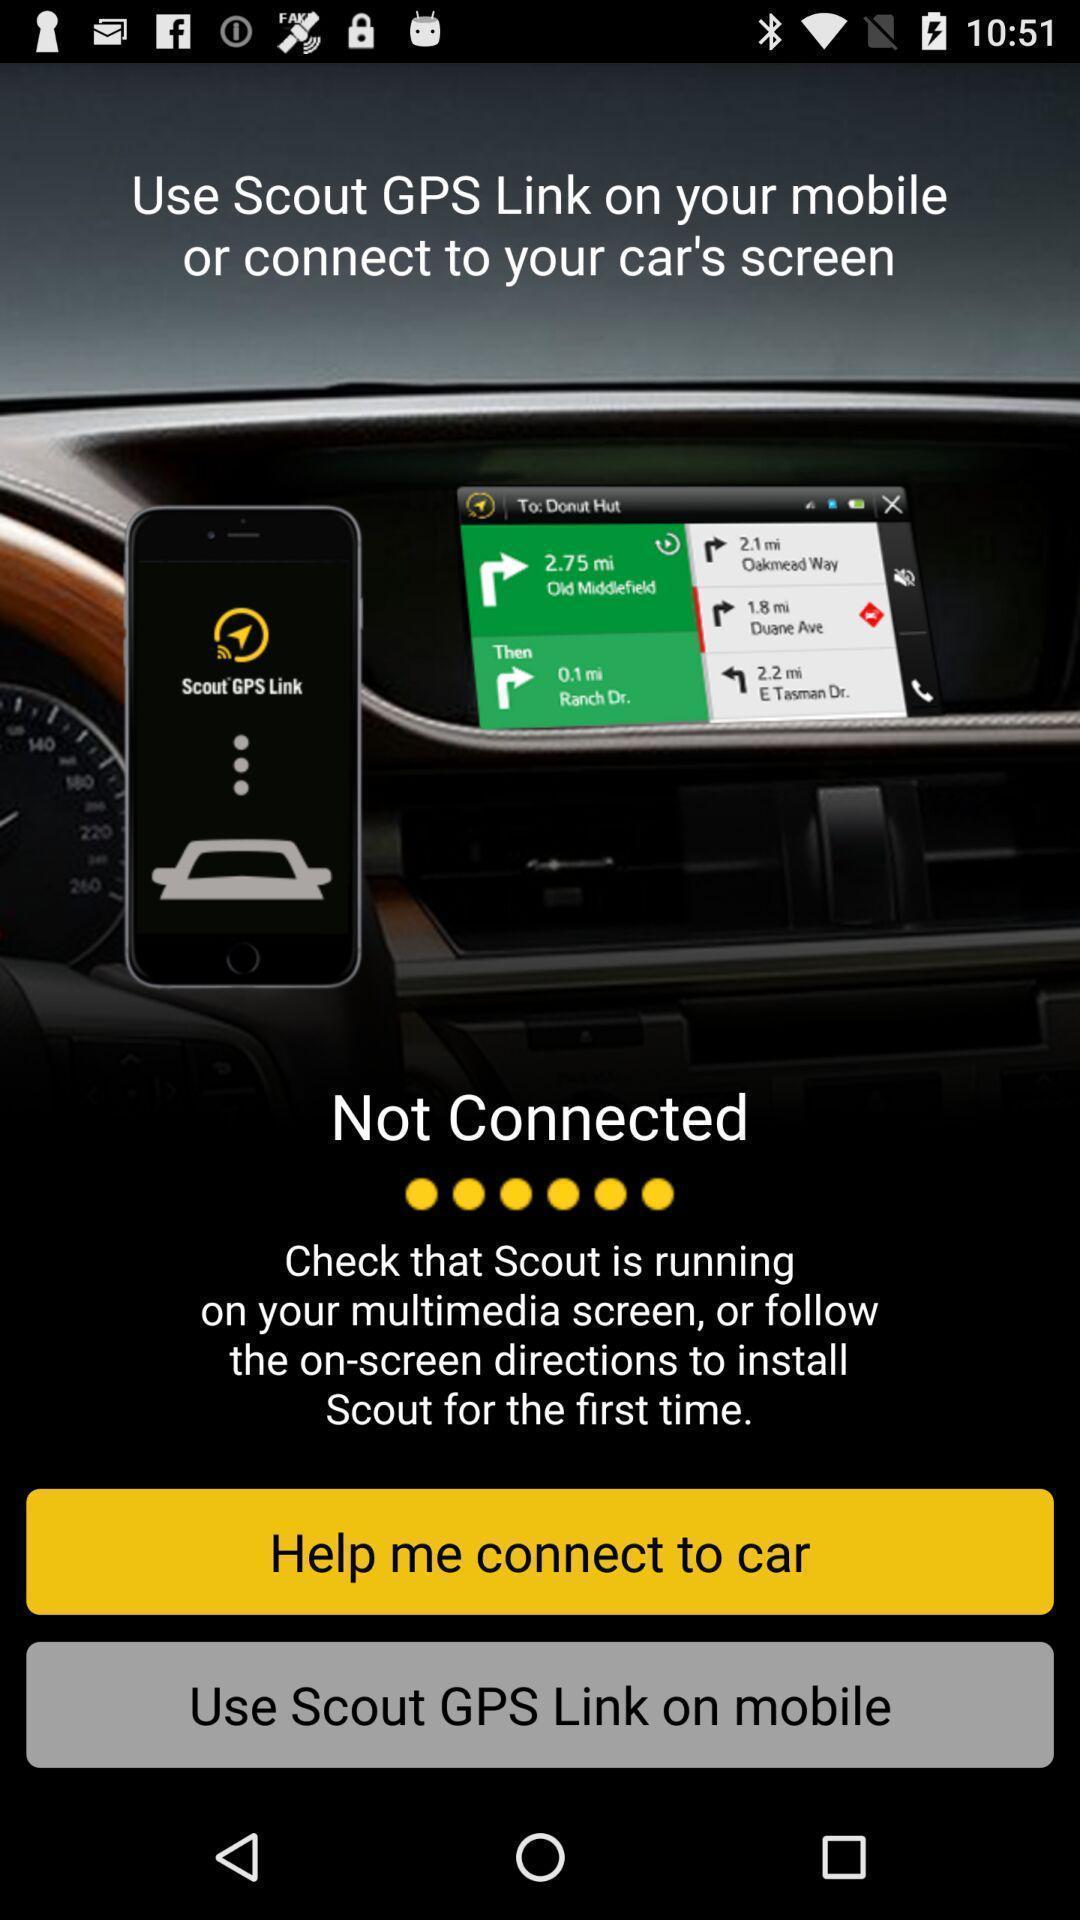Summarize the information in this screenshot. Screen page showing various options. 